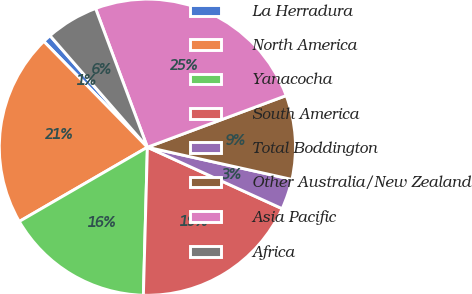<chart> <loc_0><loc_0><loc_500><loc_500><pie_chart><fcel>La Herradura<fcel>North America<fcel>Yanacocha<fcel>South America<fcel>Total Boddington<fcel>Other Australia/New Zealand<fcel>Asia Pacific<fcel>Africa<nl><fcel>0.91%<fcel>21.03%<fcel>16.21%<fcel>18.62%<fcel>3.32%<fcel>9.16%<fcel>25.02%<fcel>5.73%<nl></chart> 